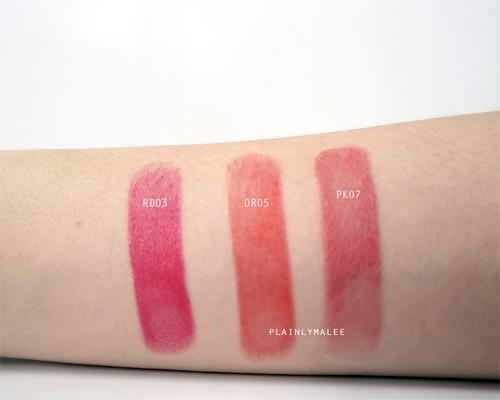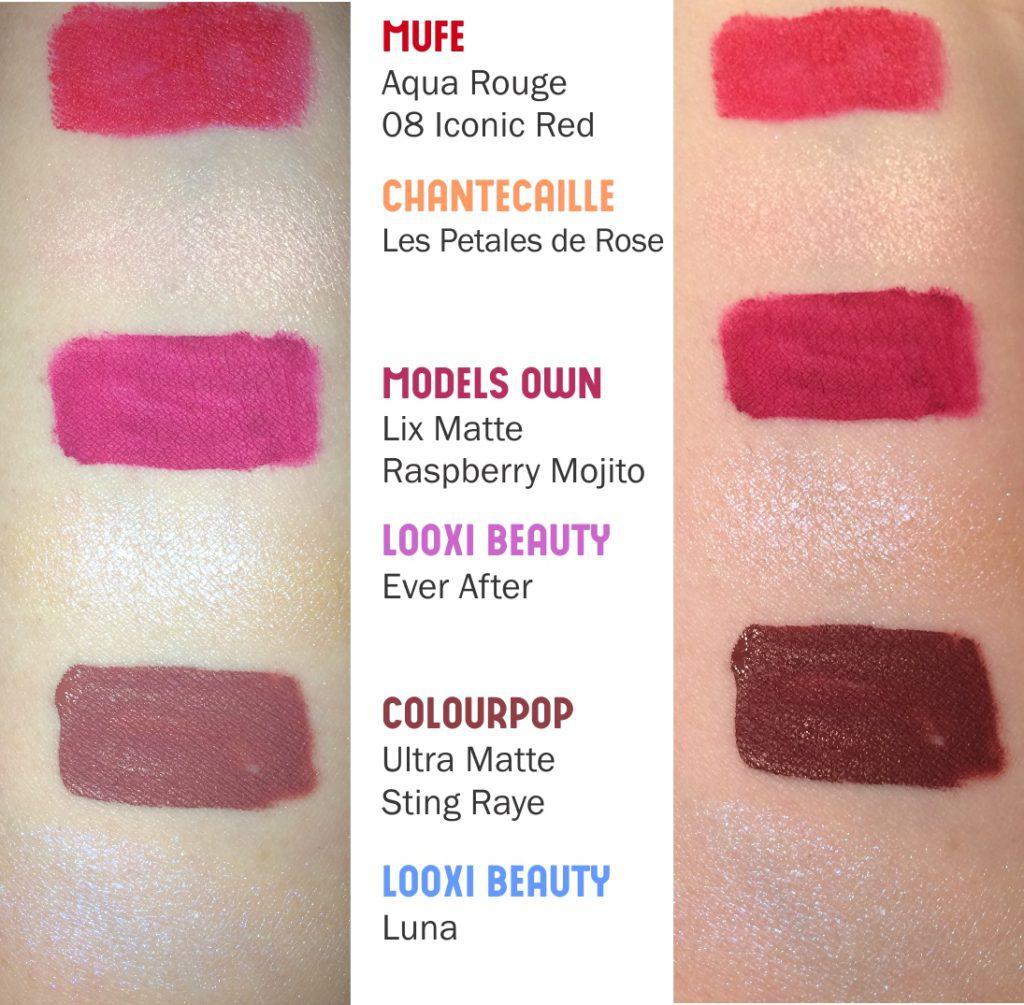The first image is the image on the left, the second image is the image on the right. For the images shown, is this caption "There are lips in one of the images." true? Answer yes or no. No. The first image is the image on the left, the second image is the image on the right. For the images displayed, is the sentence "At least two pairs of lips are visible." factually correct? Answer yes or no. No. 